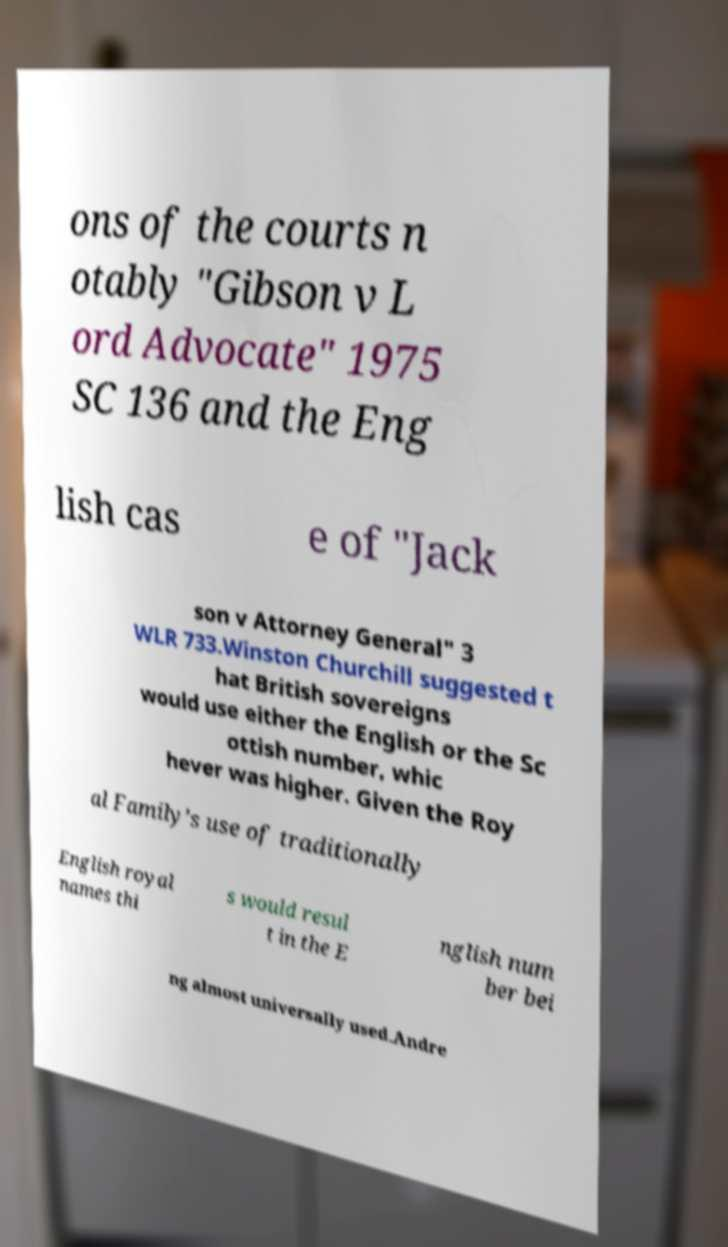Please read and relay the text visible in this image. What does it say? ons of the courts n otably "Gibson v L ord Advocate" 1975 SC 136 and the Eng lish cas e of "Jack son v Attorney General" 3 WLR 733.Winston Churchill suggested t hat British sovereigns would use either the English or the Sc ottish number, whic hever was higher. Given the Roy al Family’s use of traditionally English royal names thi s would resul t in the E nglish num ber bei ng almost universally used.Andre 